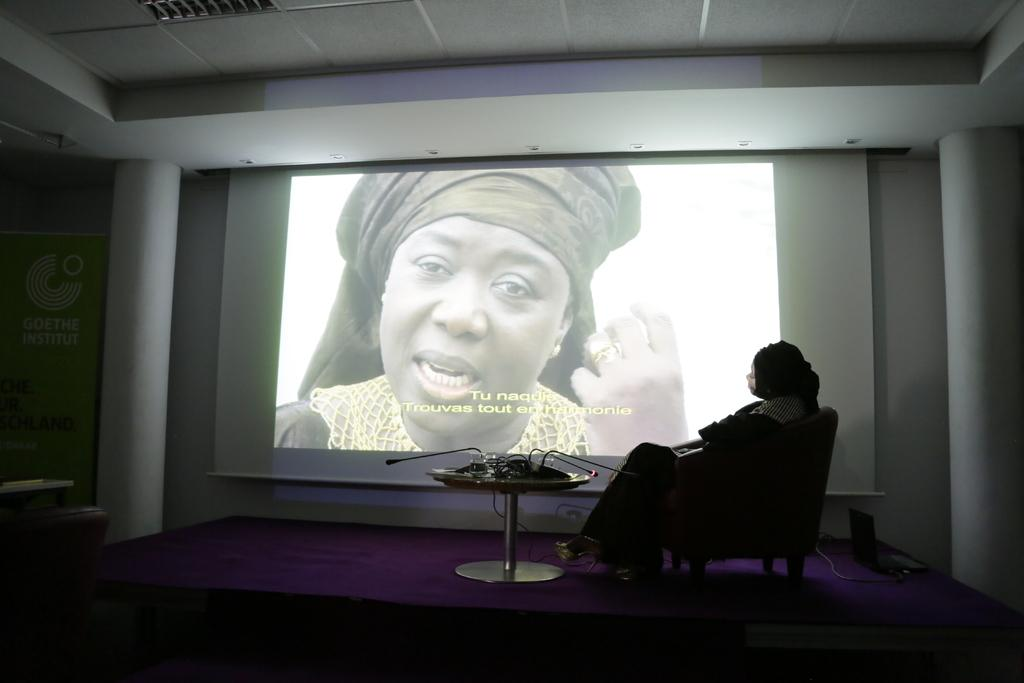Who is present in the image? There is a woman in the image. What is the woman doing in the image? The woman is sitting on a chair. What type of furniture is present in the image? There is a round center table in the image. What is the large object in the background of the image? There is a big projector screen in the image. What type of quince is being served on the round center table in the image? There is no quince present in the image; it only features a woman sitting on a chair, a round center table, and a big projector screen. 